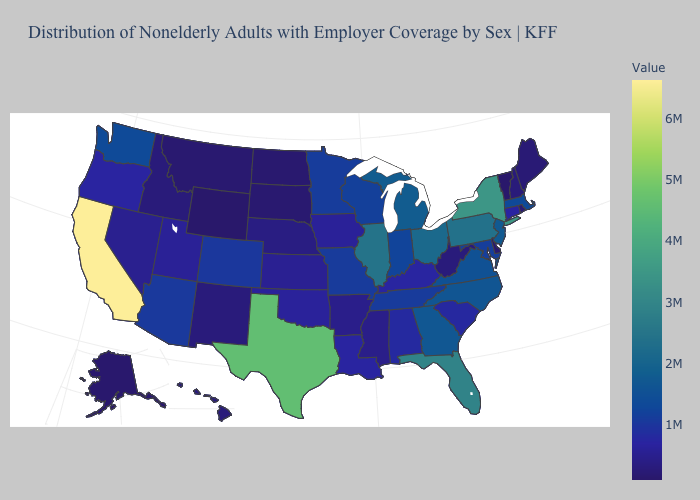Is the legend a continuous bar?
Short answer required. Yes. Does Massachusetts have a higher value than New York?
Answer briefly. No. Which states hav the highest value in the MidWest?
Quick response, please. Illinois. Among the states that border Virginia , does Kentucky have the lowest value?
Be succinct. No. Does Iowa have a higher value than Georgia?
Keep it brief. No. 